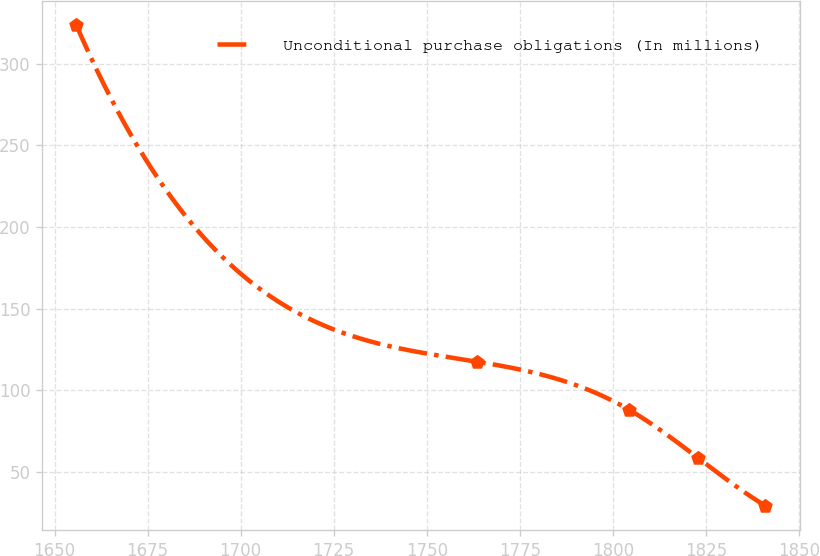Convert chart to OTSL. <chart><loc_0><loc_0><loc_500><loc_500><line_chart><ecel><fcel>Unconditional purchase obligations (In millions)<nl><fcel>1655.87<fcel>323.6<nl><fcel>1763.54<fcel>117.62<nl><fcel>1804.33<fcel>88.2<nl><fcel>1822.8<fcel>58.78<nl><fcel>1840.95<fcel>29.35<nl></chart> 